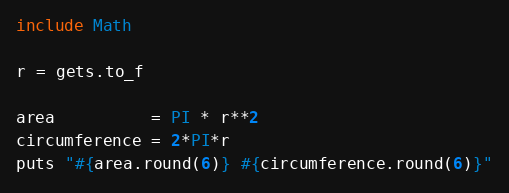<code> <loc_0><loc_0><loc_500><loc_500><_Ruby_>include Math

r = gets.to_f

area          = PI * r**2
circumference = 2*PI*r
puts "#{area.round(6)} #{circumference.round(6)}"</code> 